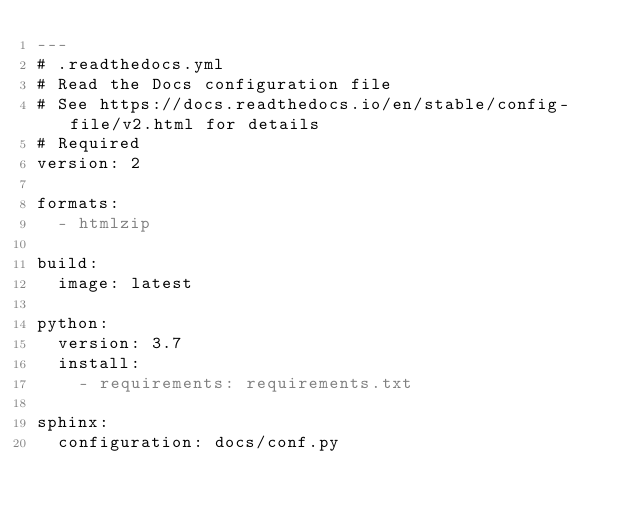Convert code to text. <code><loc_0><loc_0><loc_500><loc_500><_YAML_>---
# .readthedocs.yml
# Read the Docs configuration file
# See https://docs.readthedocs.io/en/stable/config-file/v2.html for details
# Required
version: 2

formats:
  - htmlzip

build:
  image: latest

python:
  version: 3.7
  install:
    - requirements: requirements.txt

sphinx:
  configuration: docs/conf.py
</code> 